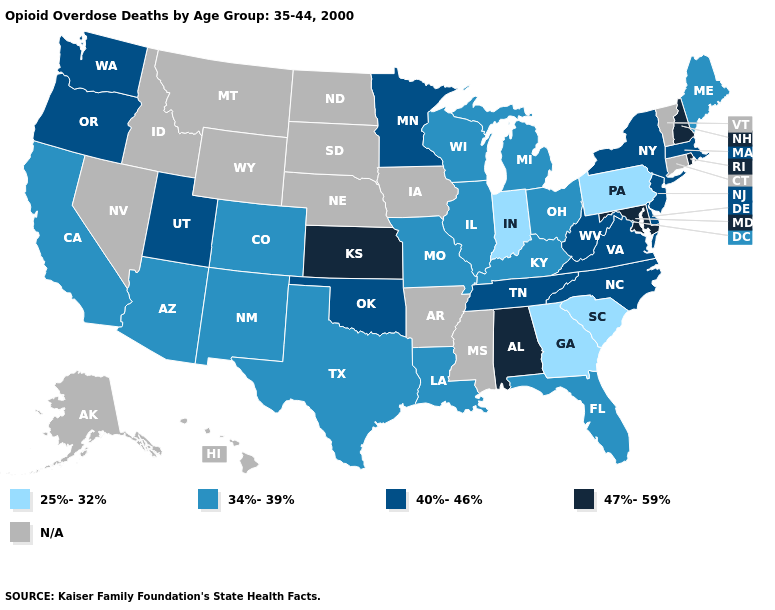Which states have the highest value in the USA?
Write a very short answer. Alabama, Kansas, Maryland, New Hampshire, Rhode Island. Name the states that have a value in the range 34%-39%?
Write a very short answer. Arizona, California, Colorado, Florida, Illinois, Kentucky, Louisiana, Maine, Michigan, Missouri, New Mexico, Ohio, Texas, Wisconsin. Among the states that border Maine , which have the highest value?
Keep it brief. New Hampshire. Name the states that have a value in the range N/A?
Write a very short answer. Alaska, Arkansas, Connecticut, Hawaii, Idaho, Iowa, Mississippi, Montana, Nebraska, Nevada, North Dakota, South Dakota, Vermont, Wyoming. Does Maryland have the highest value in the South?
Keep it brief. Yes. Does Washington have the highest value in the West?
Write a very short answer. Yes. Which states have the lowest value in the USA?
Concise answer only. Georgia, Indiana, Pennsylvania, South Carolina. What is the value of Louisiana?
Concise answer only. 34%-39%. What is the value of New Hampshire?
Concise answer only. 47%-59%. Does Pennsylvania have the highest value in the USA?
Keep it brief. No. What is the value of Arkansas?
Keep it brief. N/A. Among the states that border Mississippi , does Alabama have the highest value?
Be succinct. Yes. Name the states that have a value in the range 25%-32%?
Keep it brief. Georgia, Indiana, Pennsylvania, South Carolina. What is the lowest value in the USA?
Concise answer only. 25%-32%. Does Arizona have the highest value in the West?
Short answer required. No. 